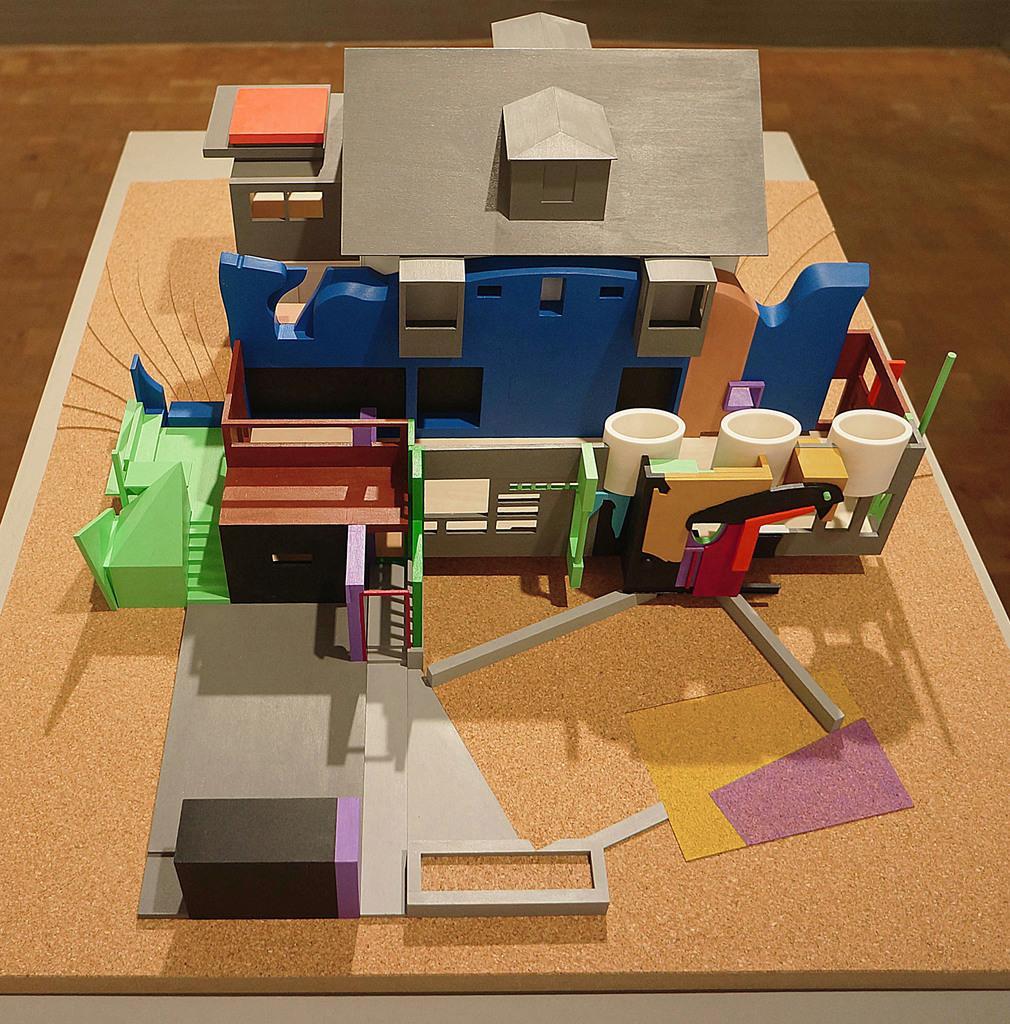Please provide a concise description of this image. In the foreground I can see a table on which a fence and a house is there. This image looks like an animated photo. 